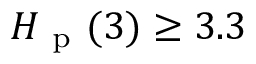Convert formula to latex. <formula><loc_0><loc_0><loc_500><loc_500>H _ { p } ( 3 ) \geq 3 . 3</formula> 